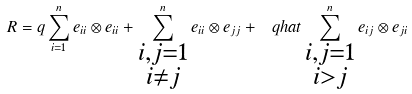<formula> <loc_0><loc_0><loc_500><loc_500>R = q \sum _ { i = 1 } ^ { n } e _ { i i } \otimes e _ { i i } + \sum ^ { n } _ { \substack { i , j = 1 \\ i \ne j } } e _ { i i } \otimes e _ { j j } + \ q h a t \sum ^ { n } _ { \substack { i , j = 1 \\ i > j } } e _ { i j } \otimes e _ { j i }</formula> 